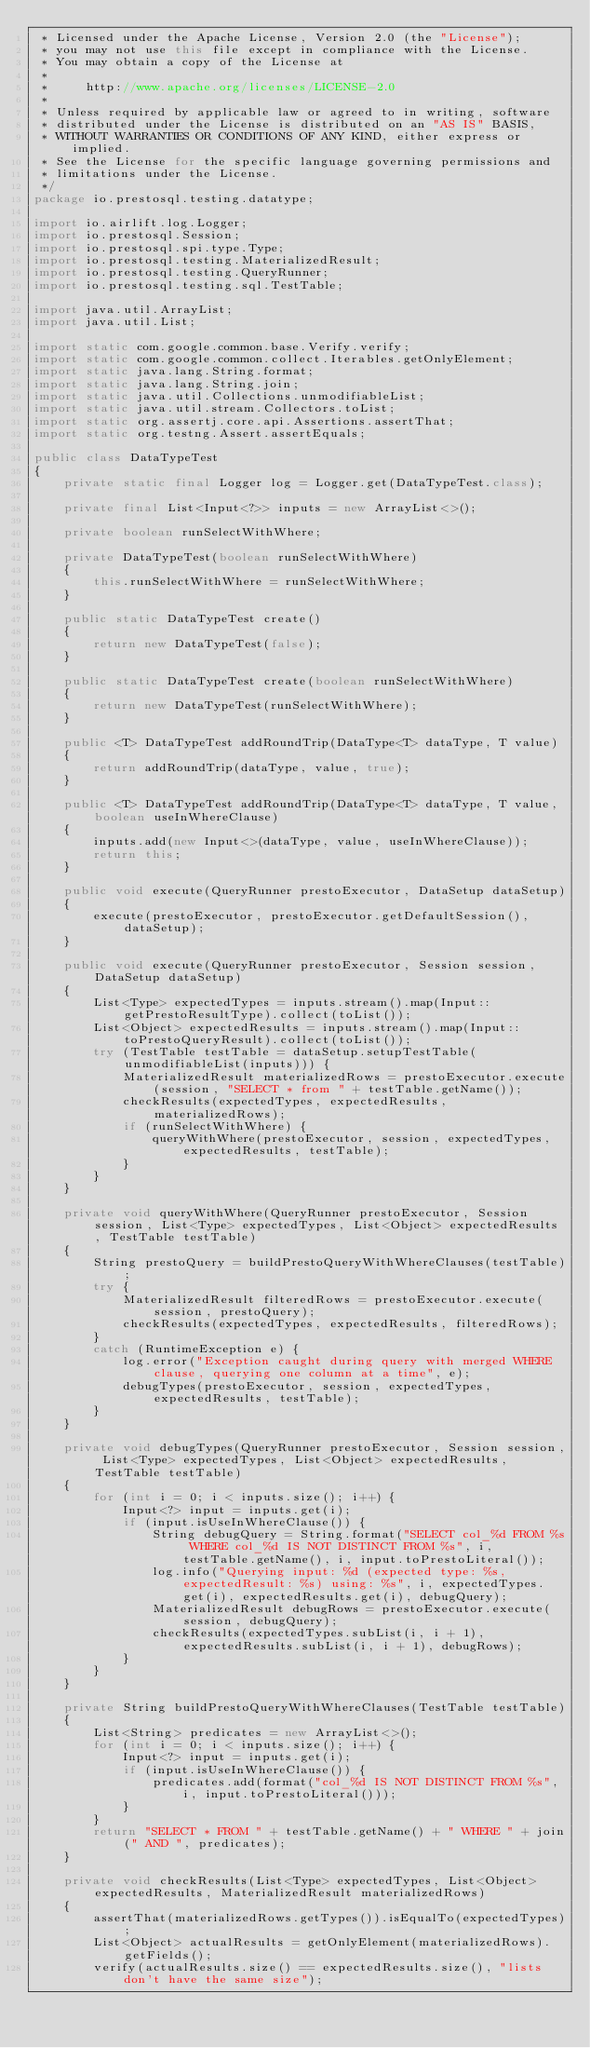<code> <loc_0><loc_0><loc_500><loc_500><_Java_> * Licensed under the Apache License, Version 2.0 (the "License");
 * you may not use this file except in compliance with the License.
 * You may obtain a copy of the License at
 *
 *     http://www.apache.org/licenses/LICENSE-2.0
 *
 * Unless required by applicable law or agreed to in writing, software
 * distributed under the License is distributed on an "AS IS" BASIS,
 * WITHOUT WARRANTIES OR CONDITIONS OF ANY KIND, either express or implied.
 * See the License for the specific language governing permissions and
 * limitations under the License.
 */
package io.prestosql.testing.datatype;

import io.airlift.log.Logger;
import io.prestosql.Session;
import io.prestosql.spi.type.Type;
import io.prestosql.testing.MaterializedResult;
import io.prestosql.testing.QueryRunner;
import io.prestosql.testing.sql.TestTable;

import java.util.ArrayList;
import java.util.List;

import static com.google.common.base.Verify.verify;
import static com.google.common.collect.Iterables.getOnlyElement;
import static java.lang.String.format;
import static java.lang.String.join;
import static java.util.Collections.unmodifiableList;
import static java.util.stream.Collectors.toList;
import static org.assertj.core.api.Assertions.assertThat;
import static org.testng.Assert.assertEquals;

public class DataTypeTest
{
    private static final Logger log = Logger.get(DataTypeTest.class);

    private final List<Input<?>> inputs = new ArrayList<>();

    private boolean runSelectWithWhere;

    private DataTypeTest(boolean runSelectWithWhere)
    {
        this.runSelectWithWhere = runSelectWithWhere;
    }

    public static DataTypeTest create()
    {
        return new DataTypeTest(false);
    }

    public static DataTypeTest create(boolean runSelectWithWhere)
    {
        return new DataTypeTest(runSelectWithWhere);
    }

    public <T> DataTypeTest addRoundTrip(DataType<T> dataType, T value)
    {
        return addRoundTrip(dataType, value, true);
    }

    public <T> DataTypeTest addRoundTrip(DataType<T> dataType, T value, boolean useInWhereClause)
    {
        inputs.add(new Input<>(dataType, value, useInWhereClause));
        return this;
    }

    public void execute(QueryRunner prestoExecutor, DataSetup dataSetup)
    {
        execute(prestoExecutor, prestoExecutor.getDefaultSession(), dataSetup);
    }

    public void execute(QueryRunner prestoExecutor, Session session, DataSetup dataSetup)
    {
        List<Type> expectedTypes = inputs.stream().map(Input::getPrestoResultType).collect(toList());
        List<Object> expectedResults = inputs.stream().map(Input::toPrestoQueryResult).collect(toList());
        try (TestTable testTable = dataSetup.setupTestTable(unmodifiableList(inputs))) {
            MaterializedResult materializedRows = prestoExecutor.execute(session, "SELECT * from " + testTable.getName());
            checkResults(expectedTypes, expectedResults, materializedRows);
            if (runSelectWithWhere) {
                queryWithWhere(prestoExecutor, session, expectedTypes, expectedResults, testTable);
            }
        }
    }

    private void queryWithWhere(QueryRunner prestoExecutor, Session session, List<Type> expectedTypes, List<Object> expectedResults, TestTable testTable)
    {
        String prestoQuery = buildPrestoQueryWithWhereClauses(testTable);
        try {
            MaterializedResult filteredRows = prestoExecutor.execute(session, prestoQuery);
            checkResults(expectedTypes, expectedResults, filteredRows);
        }
        catch (RuntimeException e) {
            log.error("Exception caught during query with merged WHERE clause, querying one column at a time", e);
            debugTypes(prestoExecutor, session, expectedTypes, expectedResults, testTable);
        }
    }

    private void debugTypes(QueryRunner prestoExecutor, Session session, List<Type> expectedTypes, List<Object> expectedResults, TestTable testTable)
    {
        for (int i = 0; i < inputs.size(); i++) {
            Input<?> input = inputs.get(i);
            if (input.isUseInWhereClause()) {
                String debugQuery = String.format("SELECT col_%d FROM %s WHERE col_%d IS NOT DISTINCT FROM %s", i, testTable.getName(), i, input.toPrestoLiteral());
                log.info("Querying input: %d (expected type: %s, expectedResult: %s) using: %s", i, expectedTypes.get(i), expectedResults.get(i), debugQuery);
                MaterializedResult debugRows = prestoExecutor.execute(session, debugQuery);
                checkResults(expectedTypes.subList(i, i + 1), expectedResults.subList(i, i + 1), debugRows);
            }
        }
    }

    private String buildPrestoQueryWithWhereClauses(TestTable testTable)
    {
        List<String> predicates = new ArrayList<>();
        for (int i = 0; i < inputs.size(); i++) {
            Input<?> input = inputs.get(i);
            if (input.isUseInWhereClause()) {
                predicates.add(format("col_%d IS NOT DISTINCT FROM %s", i, input.toPrestoLiteral()));
            }
        }
        return "SELECT * FROM " + testTable.getName() + " WHERE " + join(" AND ", predicates);
    }

    private void checkResults(List<Type> expectedTypes, List<Object> expectedResults, MaterializedResult materializedRows)
    {
        assertThat(materializedRows.getTypes()).isEqualTo(expectedTypes);
        List<Object> actualResults = getOnlyElement(materializedRows).getFields();
        verify(actualResults.size() == expectedResults.size(), "lists don't have the same size");</code> 